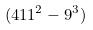<formula> <loc_0><loc_0><loc_500><loc_500>( 4 1 1 ^ { 2 } - 9 ^ { 3 } )</formula> 